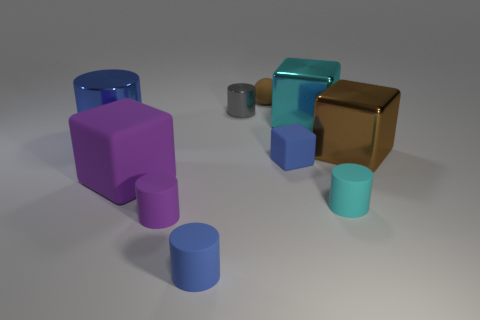Subtract all small matte cylinders. How many cylinders are left? 2 Subtract all yellow spheres. How many blue cylinders are left? 2 Subtract all cyan cubes. How many cubes are left? 3 Subtract all spheres. How many objects are left? 9 Subtract 1 cyan cylinders. How many objects are left? 9 Subtract 1 cubes. How many cubes are left? 3 Subtract all gray cylinders. Subtract all purple blocks. How many cylinders are left? 4 Subtract all brown balls. Subtract all large purple things. How many objects are left? 8 Add 9 small balls. How many small balls are left? 10 Add 6 small cyan matte spheres. How many small cyan matte spheres exist? 6 